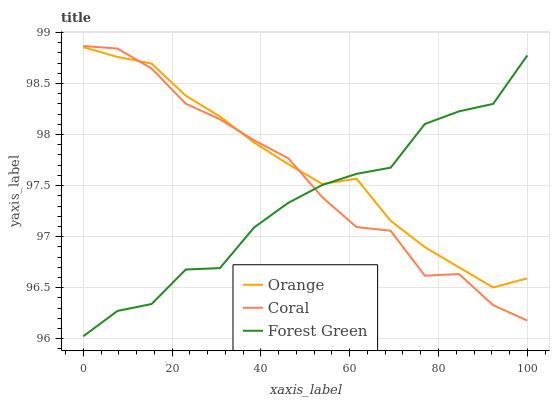Does Forest Green have the minimum area under the curve?
Answer yes or no. Yes. Does Orange have the maximum area under the curve?
Answer yes or no. Yes. Does Coral have the minimum area under the curve?
Answer yes or no. No. Does Coral have the maximum area under the curve?
Answer yes or no. No. Is Orange the smoothest?
Answer yes or no. Yes. Is Forest Green the roughest?
Answer yes or no. Yes. Is Coral the smoothest?
Answer yes or no. No. Is Coral the roughest?
Answer yes or no. No. Does Forest Green have the lowest value?
Answer yes or no. Yes. Does Coral have the lowest value?
Answer yes or no. No. Does Coral have the highest value?
Answer yes or no. Yes. Does Forest Green have the highest value?
Answer yes or no. No. Does Forest Green intersect Orange?
Answer yes or no. Yes. Is Forest Green less than Orange?
Answer yes or no. No. Is Forest Green greater than Orange?
Answer yes or no. No. 